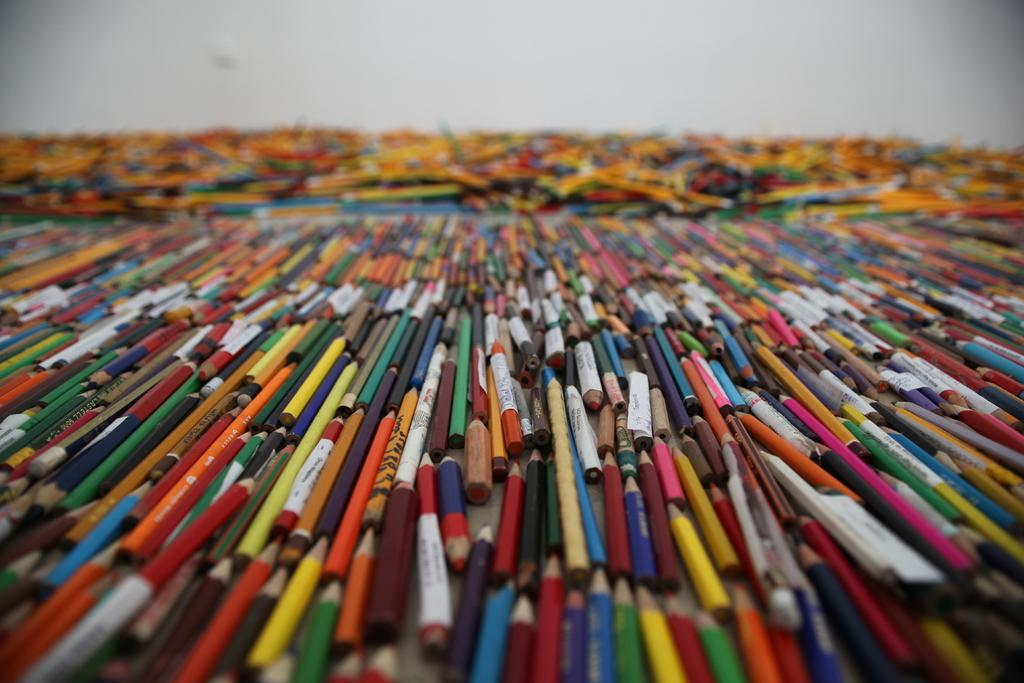What is the main subject of the image? The main subject of the image is many coloring pencils. What can be observed about the coloring pencils in the image? The coloring pencils are the main focus of the image. What is visible in the background of the image? There is a plain wall in the background of the image. What type of quartz can be seen in the image? There is no quartz present in the image. Can you describe the giraffe's behavior in the image? There is no giraffe present in the image. 